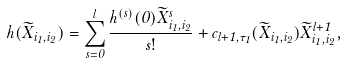<formula> <loc_0><loc_0><loc_500><loc_500>h ( \widetilde { X } _ { i _ { 1 } , i _ { 2 } } ) = \sum ^ { l } _ { s = 0 } \frac { h ^ { ( s ) } ( 0 ) \widetilde { X } _ { i _ { 1 } , i _ { 2 } } ^ { s } } { s ! } + c _ { l + 1 , \tau _ { 1 } } ( \widetilde { X } _ { i _ { 1 } , i _ { 2 } } ) \widetilde { X } _ { i _ { 1 } , i _ { 2 } } ^ { l + 1 } ,</formula> 